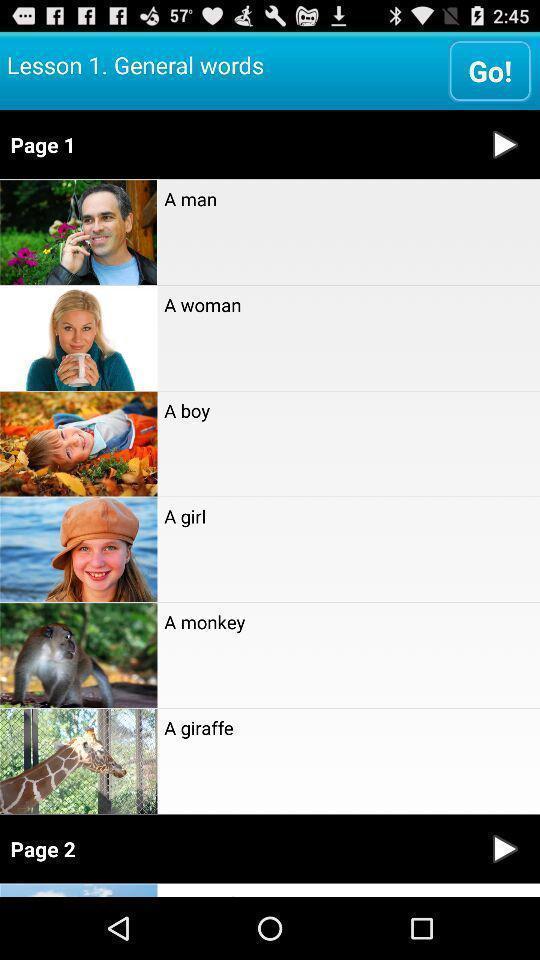Tell me what you see in this picture. Page displays general words in learning app. 